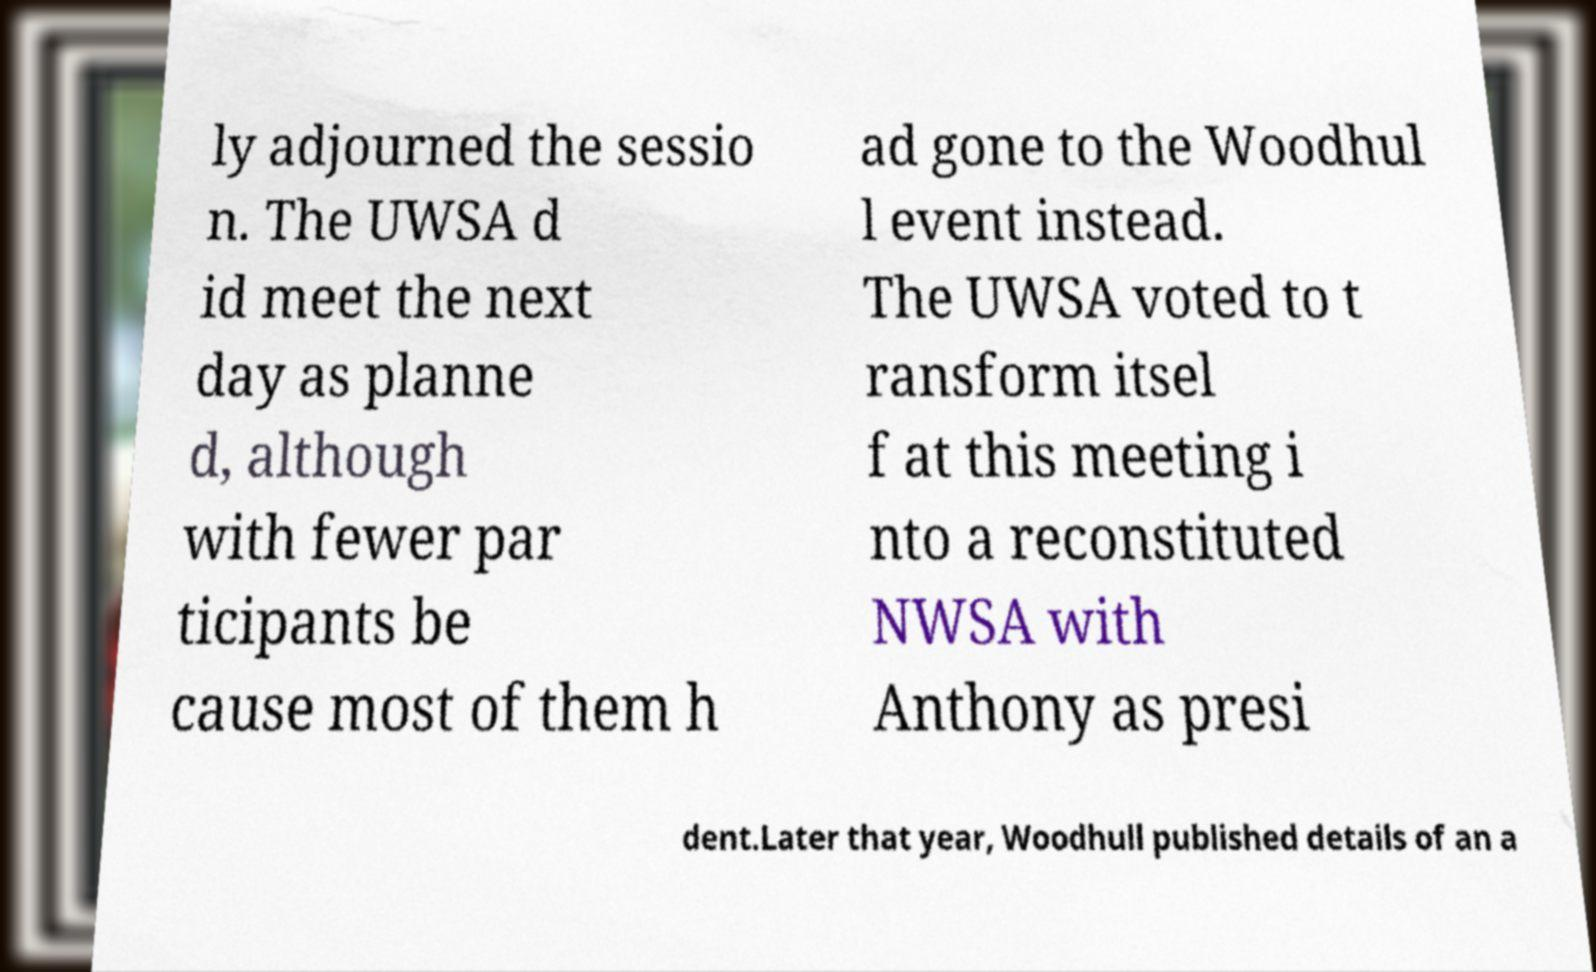For documentation purposes, I need the text within this image transcribed. Could you provide that? ly adjourned the sessio n. The UWSA d id meet the next day as planne d, although with fewer par ticipants be cause most of them h ad gone to the Woodhul l event instead. The UWSA voted to t ransform itsel f at this meeting i nto a reconstituted NWSA with Anthony as presi dent.Later that year, Woodhull published details of an a 